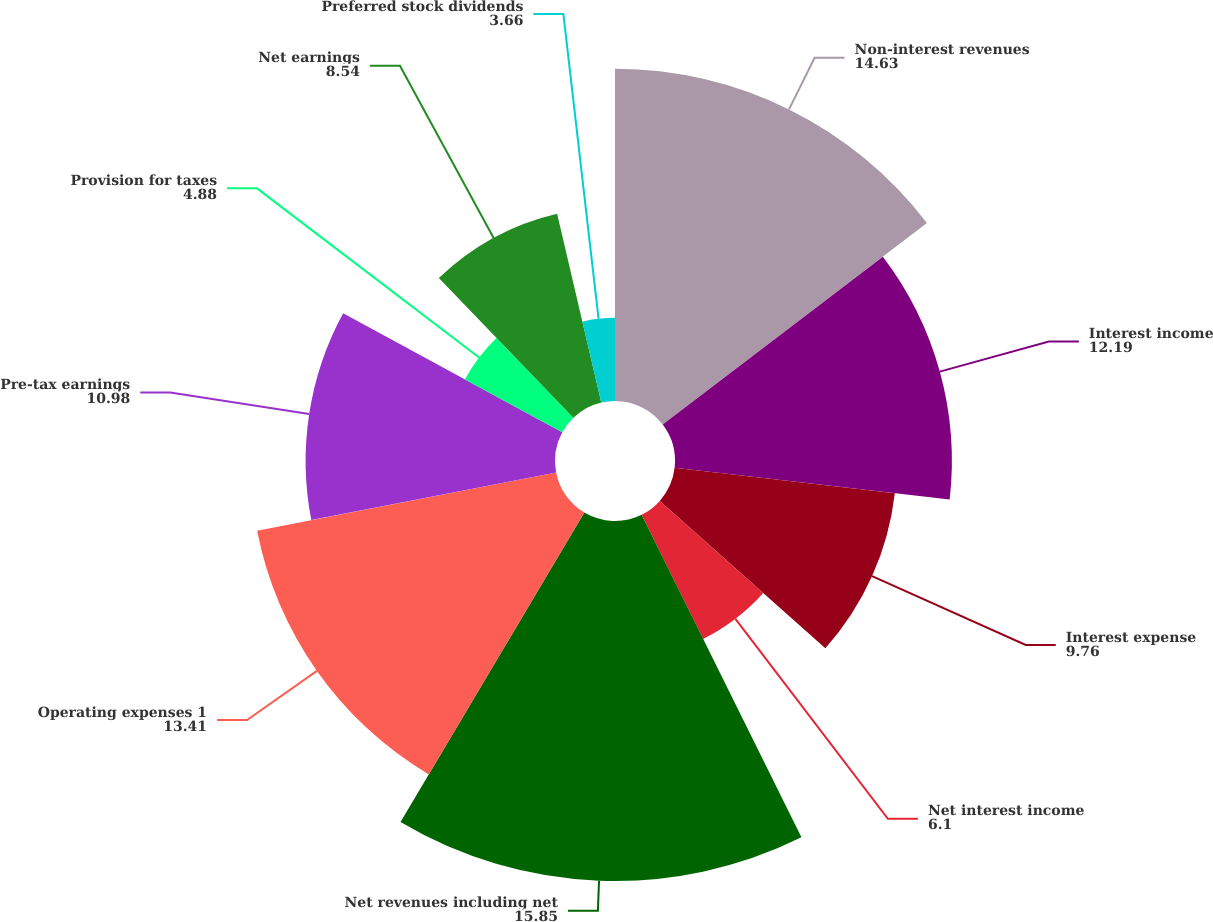<chart> <loc_0><loc_0><loc_500><loc_500><pie_chart><fcel>Non-interest revenues<fcel>Interest income<fcel>Interest expense<fcel>Net interest income<fcel>Net revenues including net<fcel>Operating expenses 1<fcel>Pre-tax earnings<fcel>Provision for taxes<fcel>Net earnings<fcel>Preferred stock dividends<nl><fcel>14.63%<fcel>12.19%<fcel>9.76%<fcel>6.1%<fcel>15.85%<fcel>13.41%<fcel>10.98%<fcel>4.88%<fcel>8.54%<fcel>3.66%<nl></chart> 